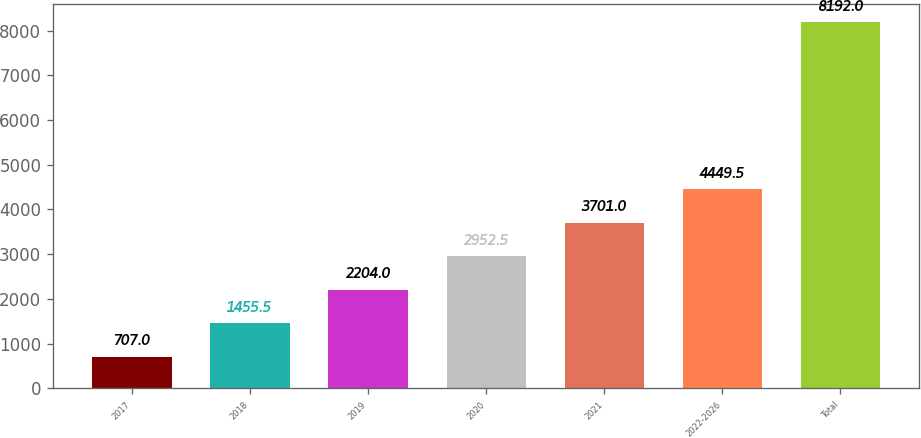Convert chart. <chart><loc_0><loc_0><loc_500><loc_500><bar_chart><fcel>2017<fcel>2018<fcel>2019<fcel>2020<fcel>2021<fcel>2022-2026<fcel>Total<nl><fcel>707<fcel>1455.5<fcel>2204<fcel>2952.5<fcel>3701<fcel>4449.5<fcel>8192<nl></chart> 